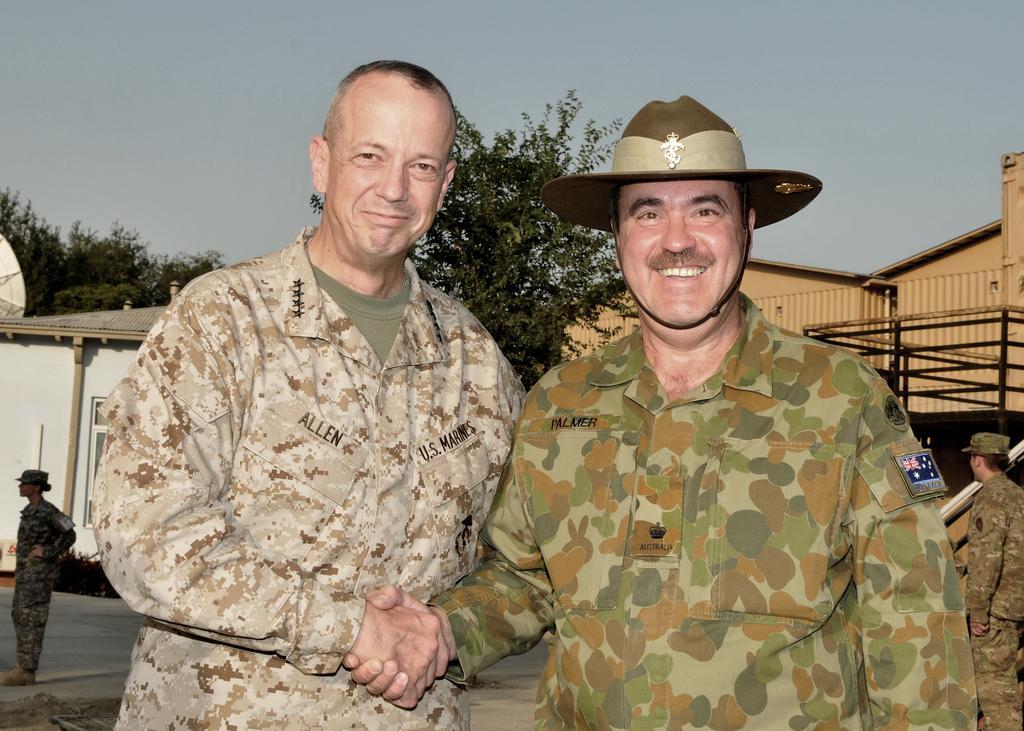In one or two sentences, can you explain what this image depicts? In this picture I can see buildings and trees in the back and I can see a woman standing on the left and a man standing on the right side of the picture and I can see a cloudy sky. 